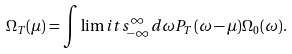<formula> <loc_0><loc_0><loc_500><loc_500>\Omega _ { T } ( \mu ) = \int \lim i t s _ { - \infty } ^ { \infty } d \omega P _ { T } ( \omega - \mu ) \Omega _ { 0 } ( \omega ) .</formula> 